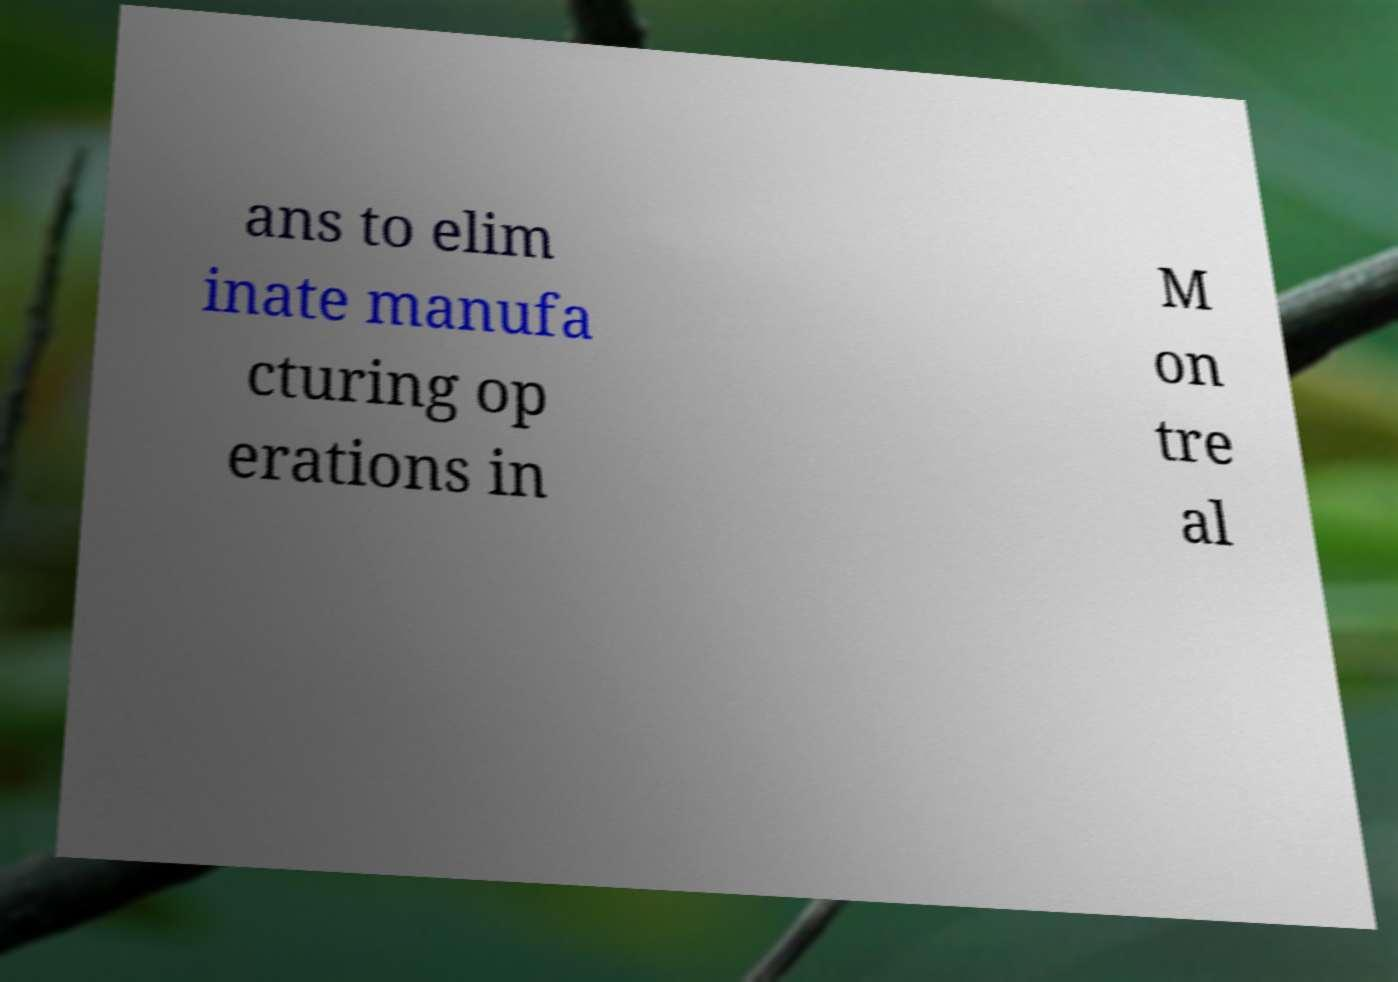Please read and relay the text visible in this image. What does it say? ans to elim inate manufa cturing op erations in M on tre al 